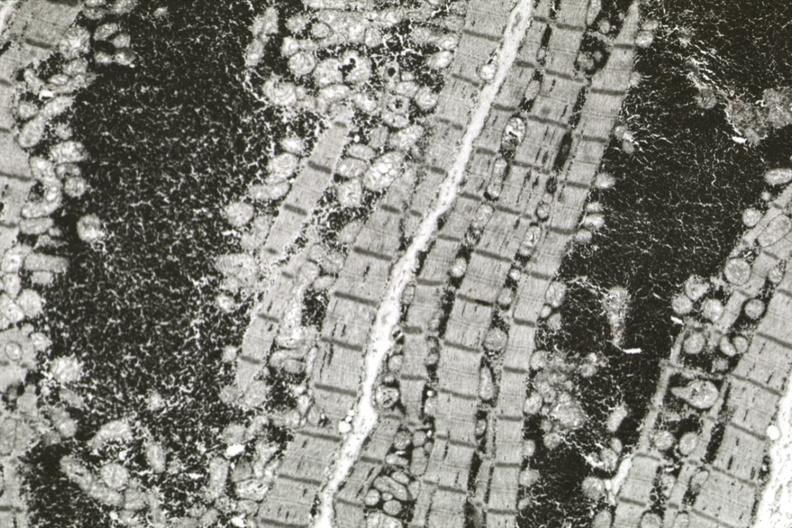where is this area in the body?
Answer the question using a single word or phrase. Heart 